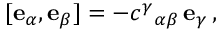Convert formula to latex. <formula><loc_0><loc_0><loc_500><loc_500>[ e _ { \alpha } , e _ { \beta } ] = - c ^ { \gamma _ { \alpha \beta } \, e _ { \gamma } \, ,</formula> 